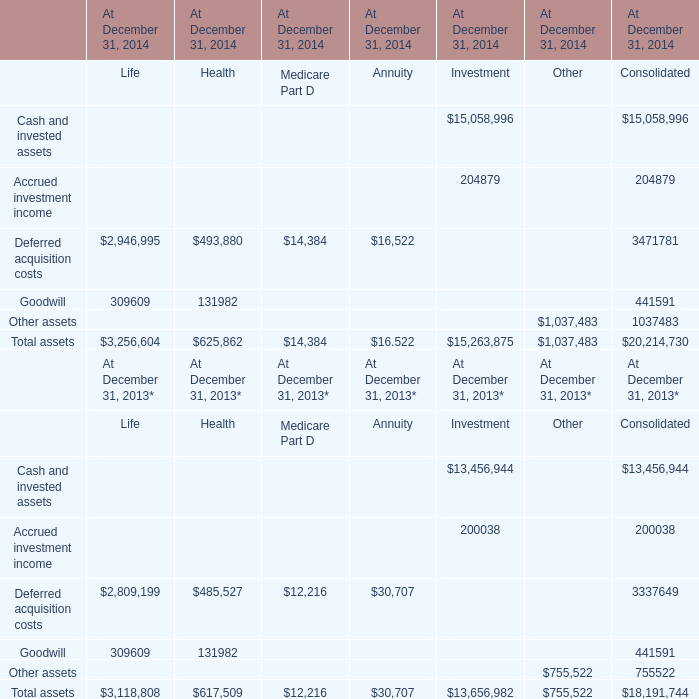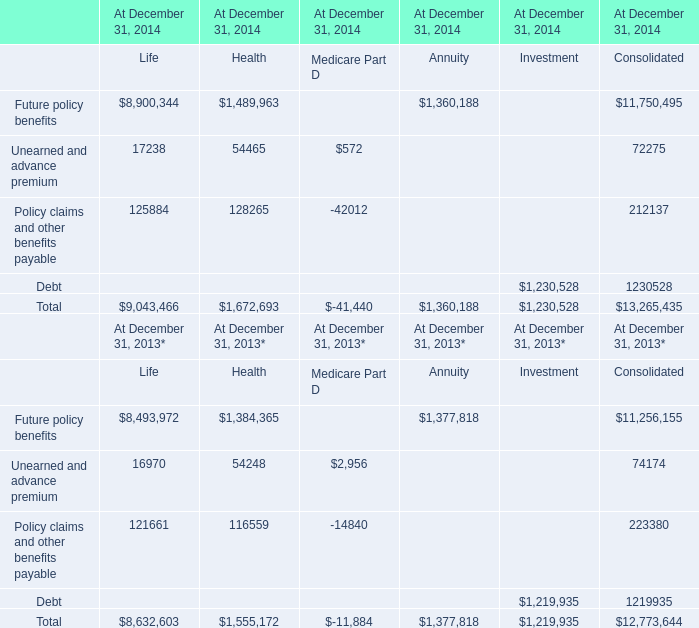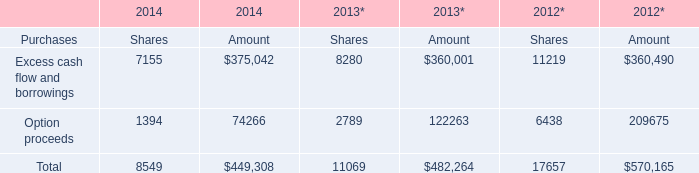for the 673 first avenue property which has been classified as a capital lease , what percent of the basis was amortized in the year december 31 , 2002? 
Computations: (3579 / 12208)
Answer: 0.29317. 